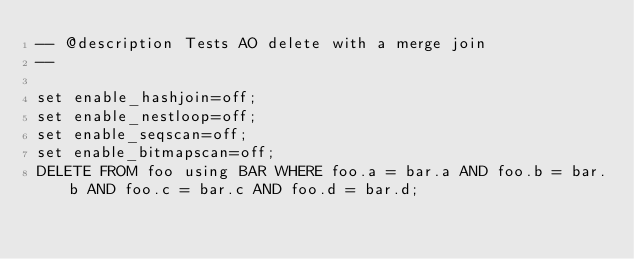Convert code to text. <code><loc_0><loc_0><loc_500><loc_500><_SQL_>-- @description Tests AO delete with a merge join
-- 

set enable_hashjoin=off;
set enable_nestloop=off;
set enable_seqscan=off;
set enable_bitmapscan=off;
DELETE FROM foo using BAR WHERE foo.a = bar.a AND foo.b = bar.b AND foo.c = bar.c AND foo.d = bar.d;
</code> 